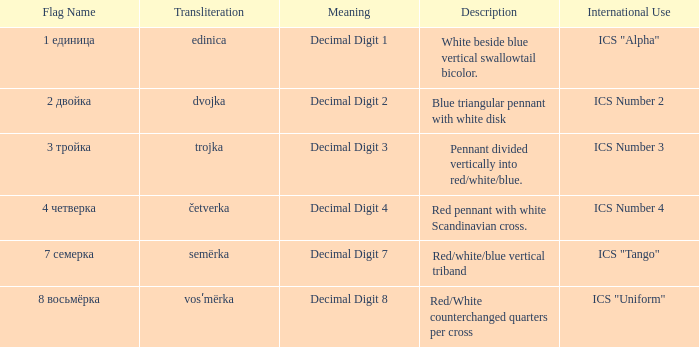What are the denotations of the flag whose name can be transliterated to dvojka? Decimal Digit 2. 